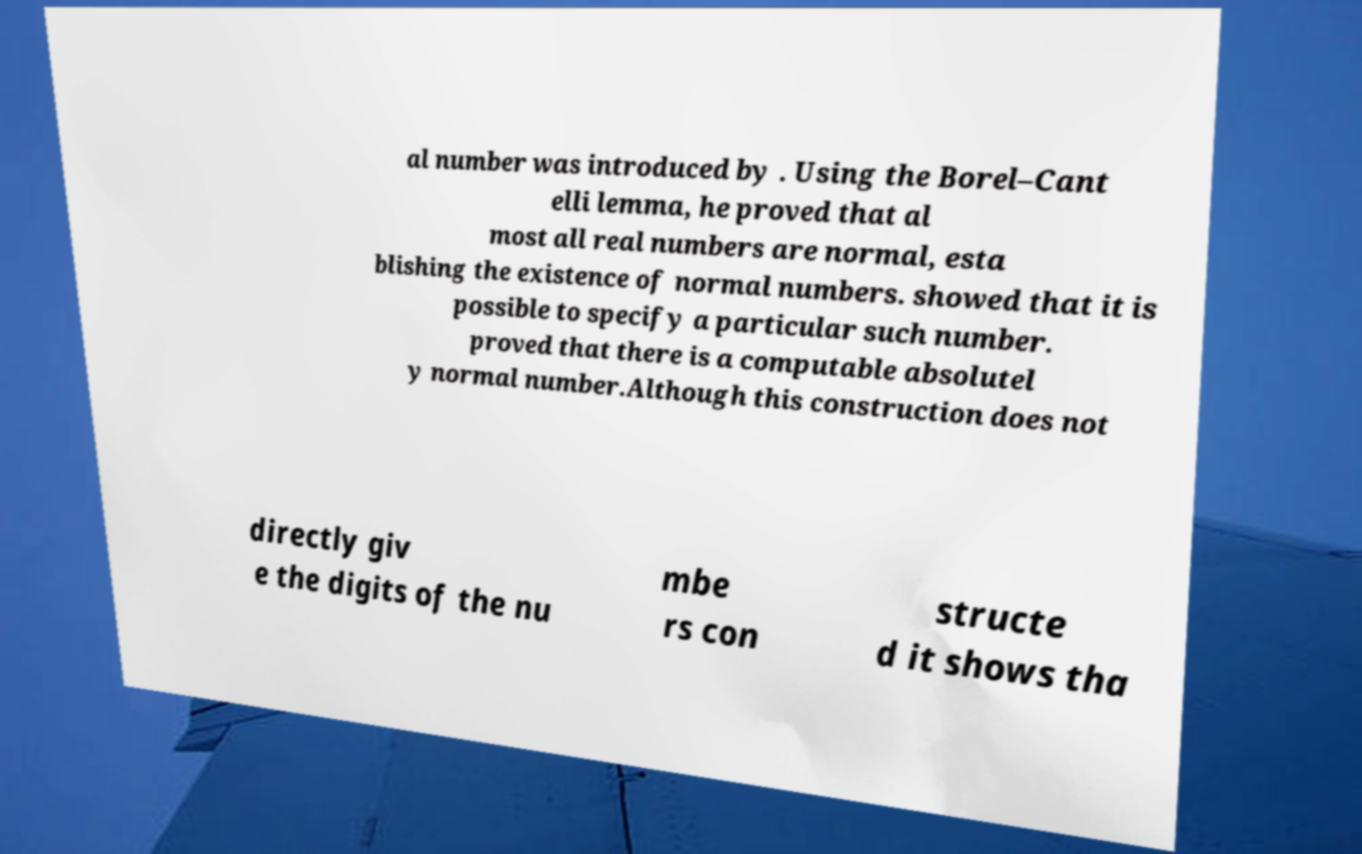Could you assist in decoding the text presented in this image and type it out clearly? al number was introduced by . Using the Borel–Cant elli lemma, he proved that al most all real numbers are normal, esta blishing the existence of normal numbers. showed that it is possible to specify a particular such number. proved that there is a computable absolutel y normal number.Although this construction does not directly giv e the digits of the nu mbe rs con structe d it shows tha 